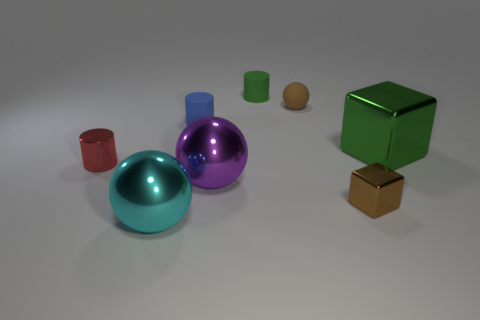Add 2 purple matte spheres. How many objects exist? 10 Subtract all tiny rubber cylinders. How many cylinders are left? 1 Subtract all green blocks. How many blocks are left? 1 Subtract all blocks. How many objects are left? 6 Subtract 1 cylinders. How many cylinders are left? 2 Subtract all green spheres. Subtract all purple cylinders. How many spheres are left? 3 Subtract all brown cylinders. How many cyan balls are left? 1 Subtract all green shiny things. Subtract all cylinders. How many objects are left? 4 Add 2 tiny brown metal things. How many tiny brown metal things are left? 3 Add 5 cyan metal objects. How many cyan metal objects exist? 6 